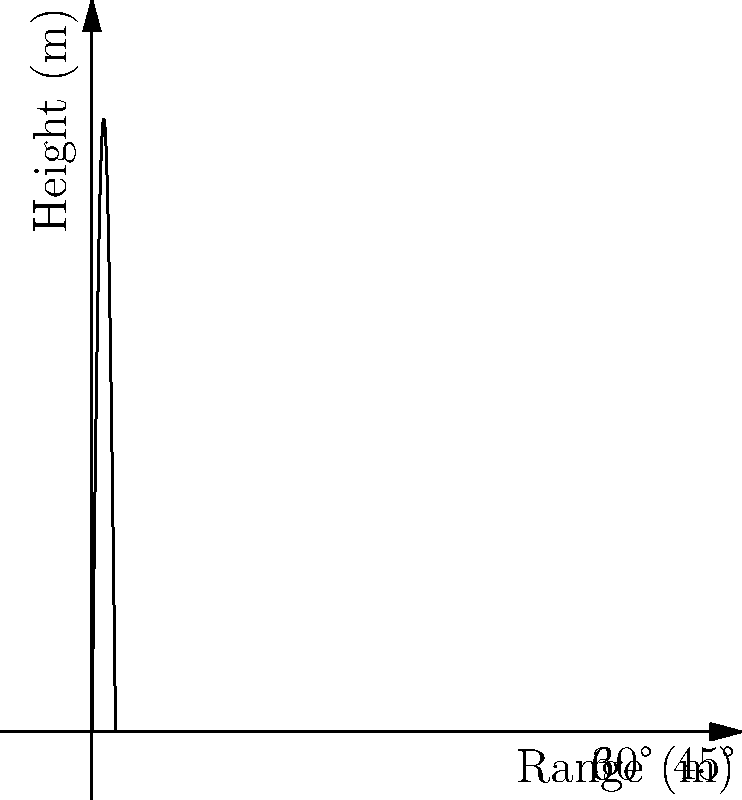A soccer player kicks a ball with an initial velocity of 20 m/s at different angles. Based on the trajectory graph shown, which angle maximizes the range of the ball, and what is the approximate maximum range achieved? To answer this question, we need to analyze the graph and apply our knowledge of projectile motion:

1. The graph shows the trajectories for three different angles: 30°, 45°, and 60°.

2. We know from projectile motion theory that the range $R$ is given by:

   $R = \frac{v_0^2 \sin(2\theta)}{g}$

   where $v_0$ is the initial velocity, $\theta$ is the launch angle, and $g$ is the acceleration due to gravity.

3. The range is maximized when $\sin(2\theta)$ is at its maximum value, which occurs when $2\theta = 90°$ or $\theta = 45°$.

4. Looking at the graph, we can see that the 45° trajectory indeed reaches the farthest horizontal distance.

5. To calculate the approximate maximum range, we can use the range equation:

   $R_{max} = \frac{v_0^2 \sin(2 \cdot 45°)}{g} = \frac{(20 \text{ m/s})^2 \cdot 1}{9.8 \text{ m/s}^2} \approx 40.8 \text{ m}$

6. From the graph, we can estimate that the maximum range is about 40 meters, which aligns with our calculation.
Answer: 45°; approximately 40 meters 